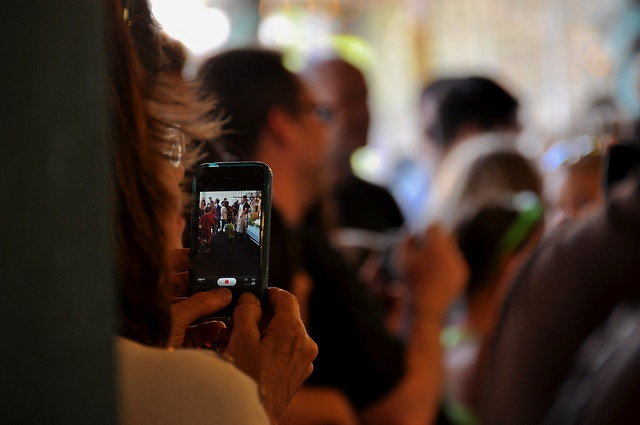Describe the objects in this image and their specific colors. I can see people in black, maroon, and brown tones, people in black, maroon, and brown tones, people in black and gray tones, people in black, maroon, gray, and brown tones, and cell phone in black, darkgray, gray, and maroon tones in this image. 